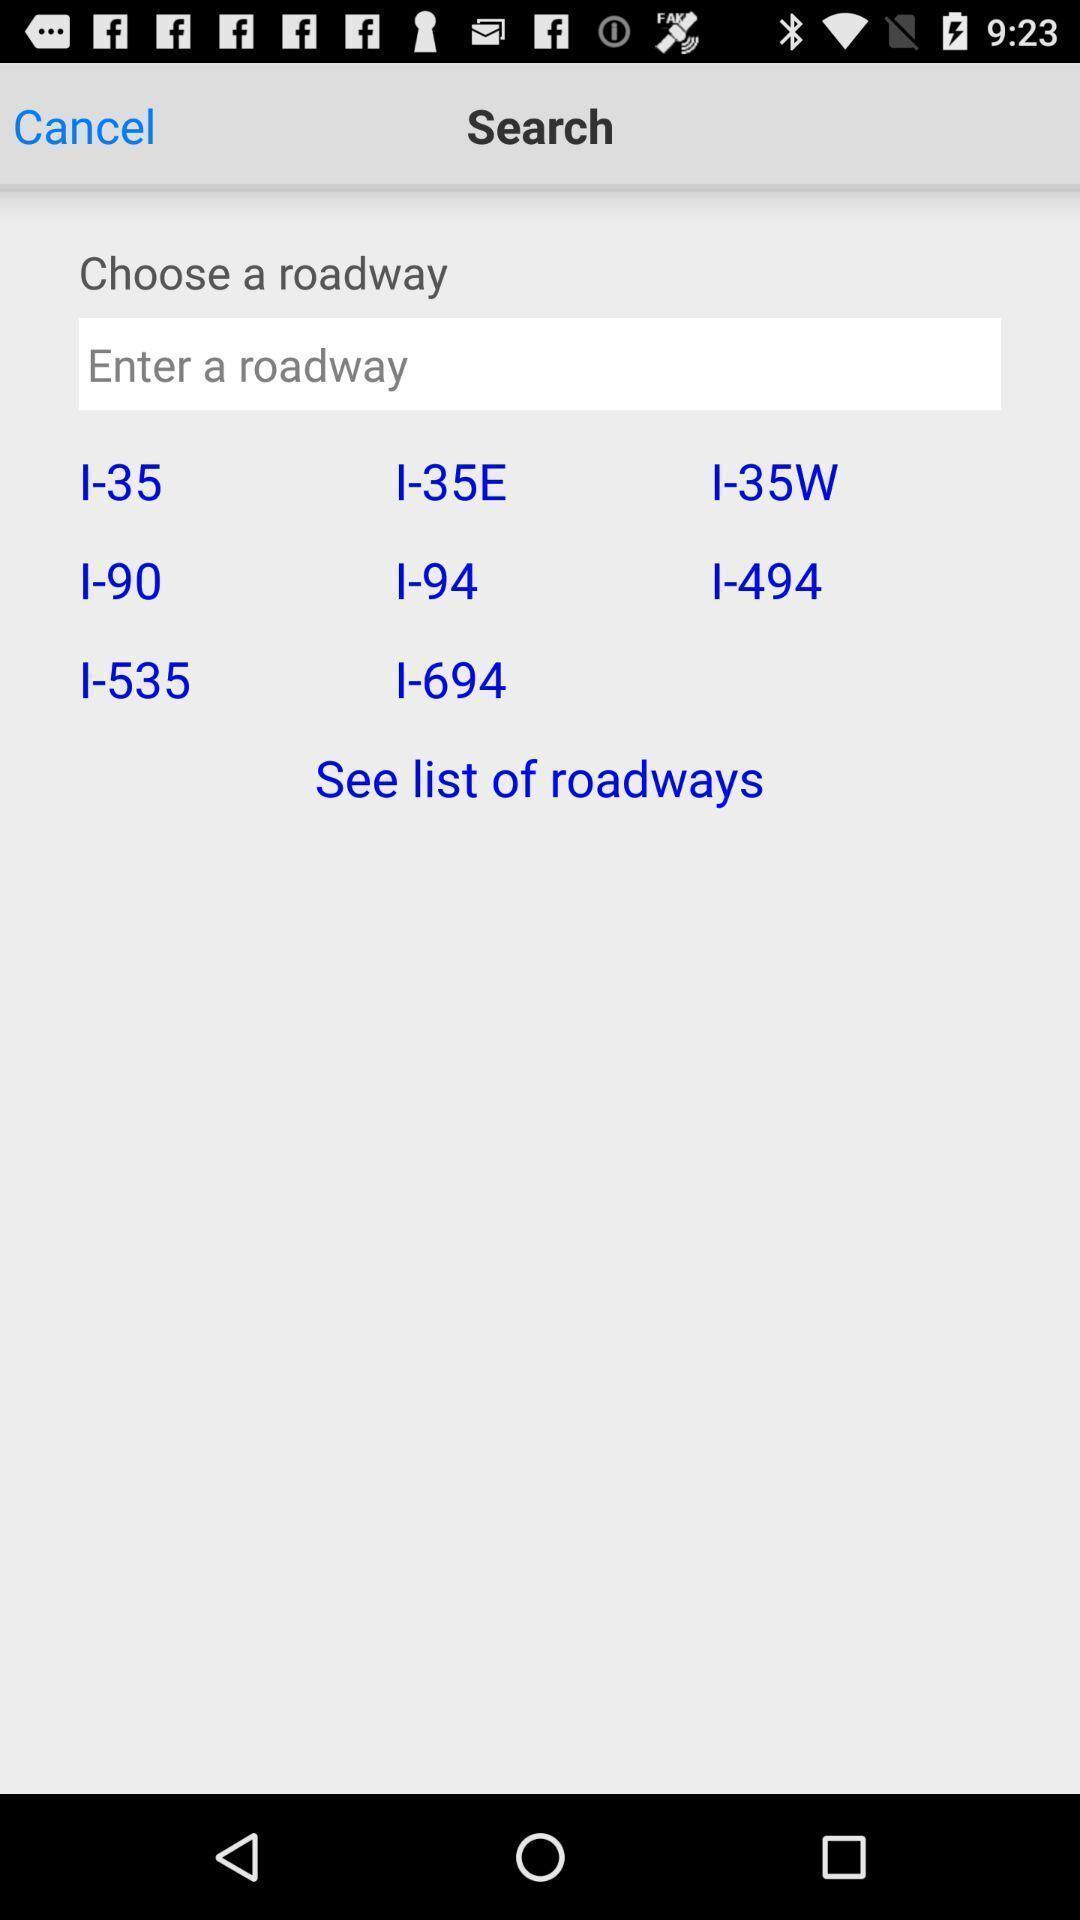Tell me about the visual elements in this screen capture. Search result page of list of roadways in travel app. 